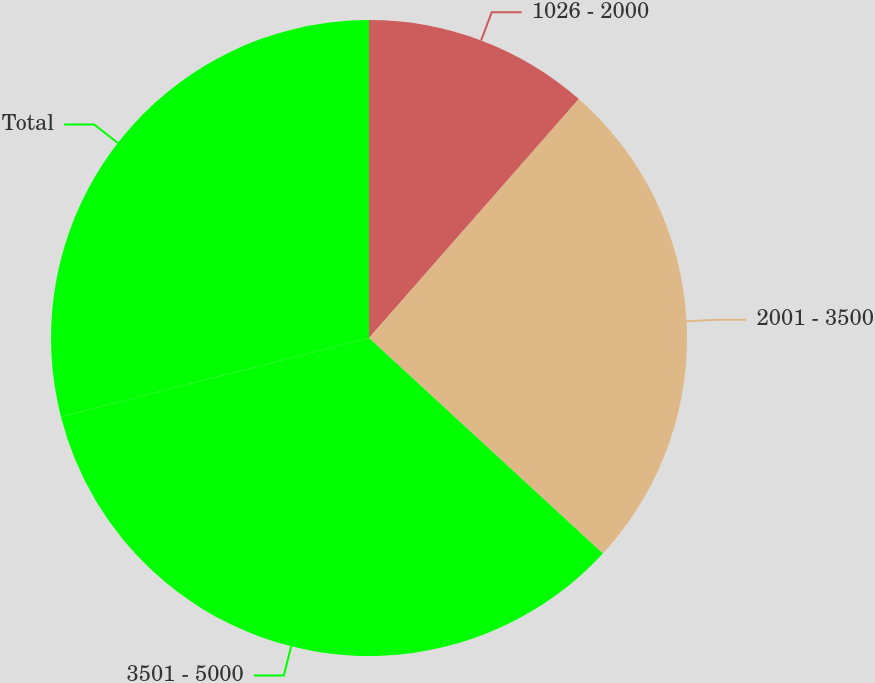Convert chart. <chart><loc_0><loc_0><loc_500><loc_500><pie_chart><fcel>1026 - 2000<fcel>2001 - 3500<fcel>3501 - 5000<fcel>Total<nl><fcel>11.47%<fcel>25.38%<fcel>34.17%<fcel>28.98%<nl></chart> 